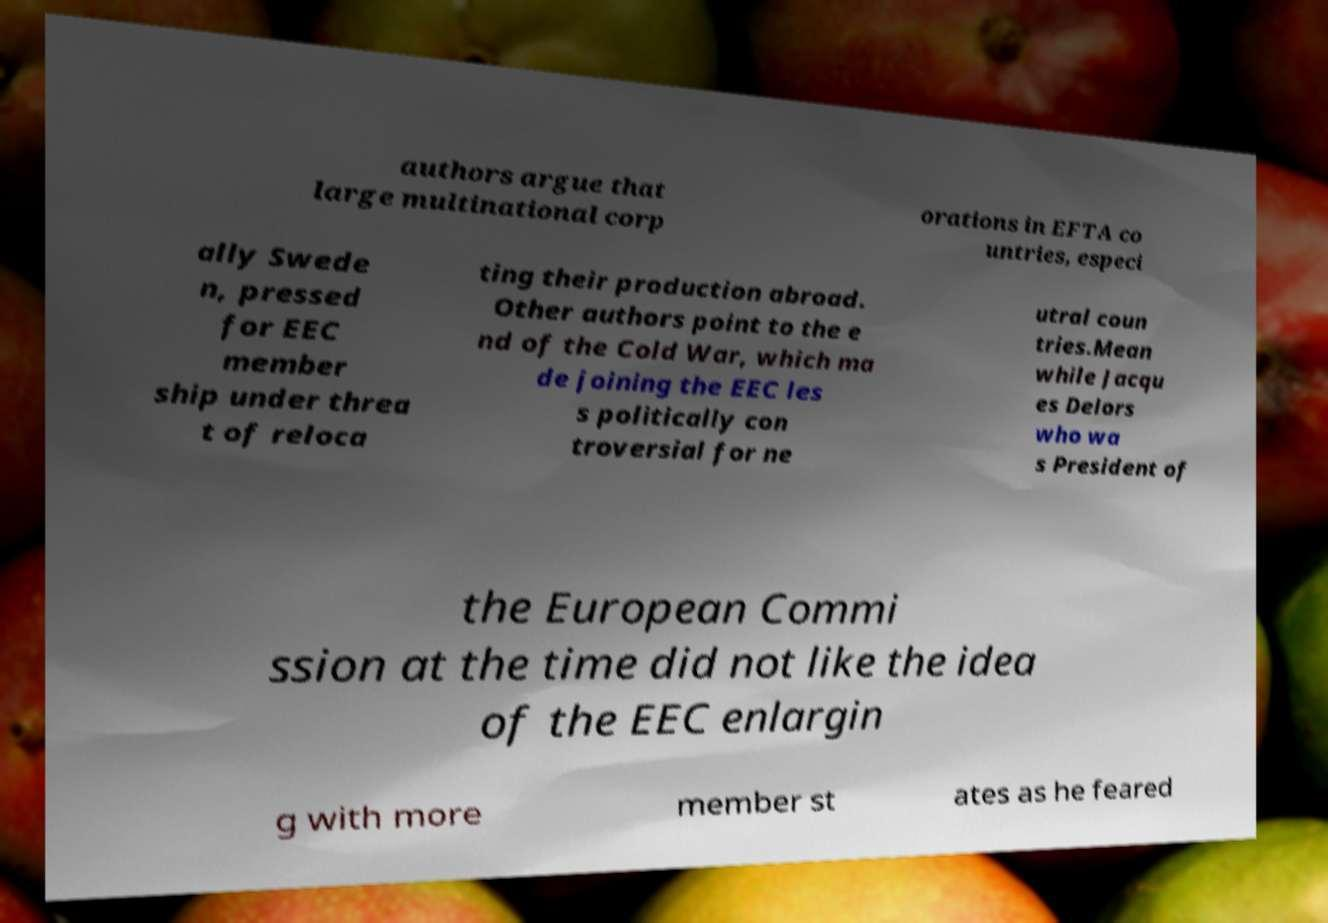Can you read and provide the text displayed in the image?This photo seems to have some interesting text. Can you extract and type it out for me? authors argue that large multinational corp orations in EFTA co untries, especi ally Swede n, pressed for EEC member ship under threa t of reloca ting their production abroad. Other authors point to the e nd of the Cold War, which ma de joining the EEC les s politically con troversial for ne utral coun tries.Mean while Jacqu es Delors who wa s President of the European Commi ssion at the time did not like the idea of the EEC enlargin g with more member st ates as he feared 